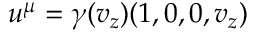<formula> <loc_0><loc_0><loc_500><loc_500>u ^ { \mu } = \gamma ( v _ { z } ) ( 1 , 0 , 0 , v _ { z } )</formula> 